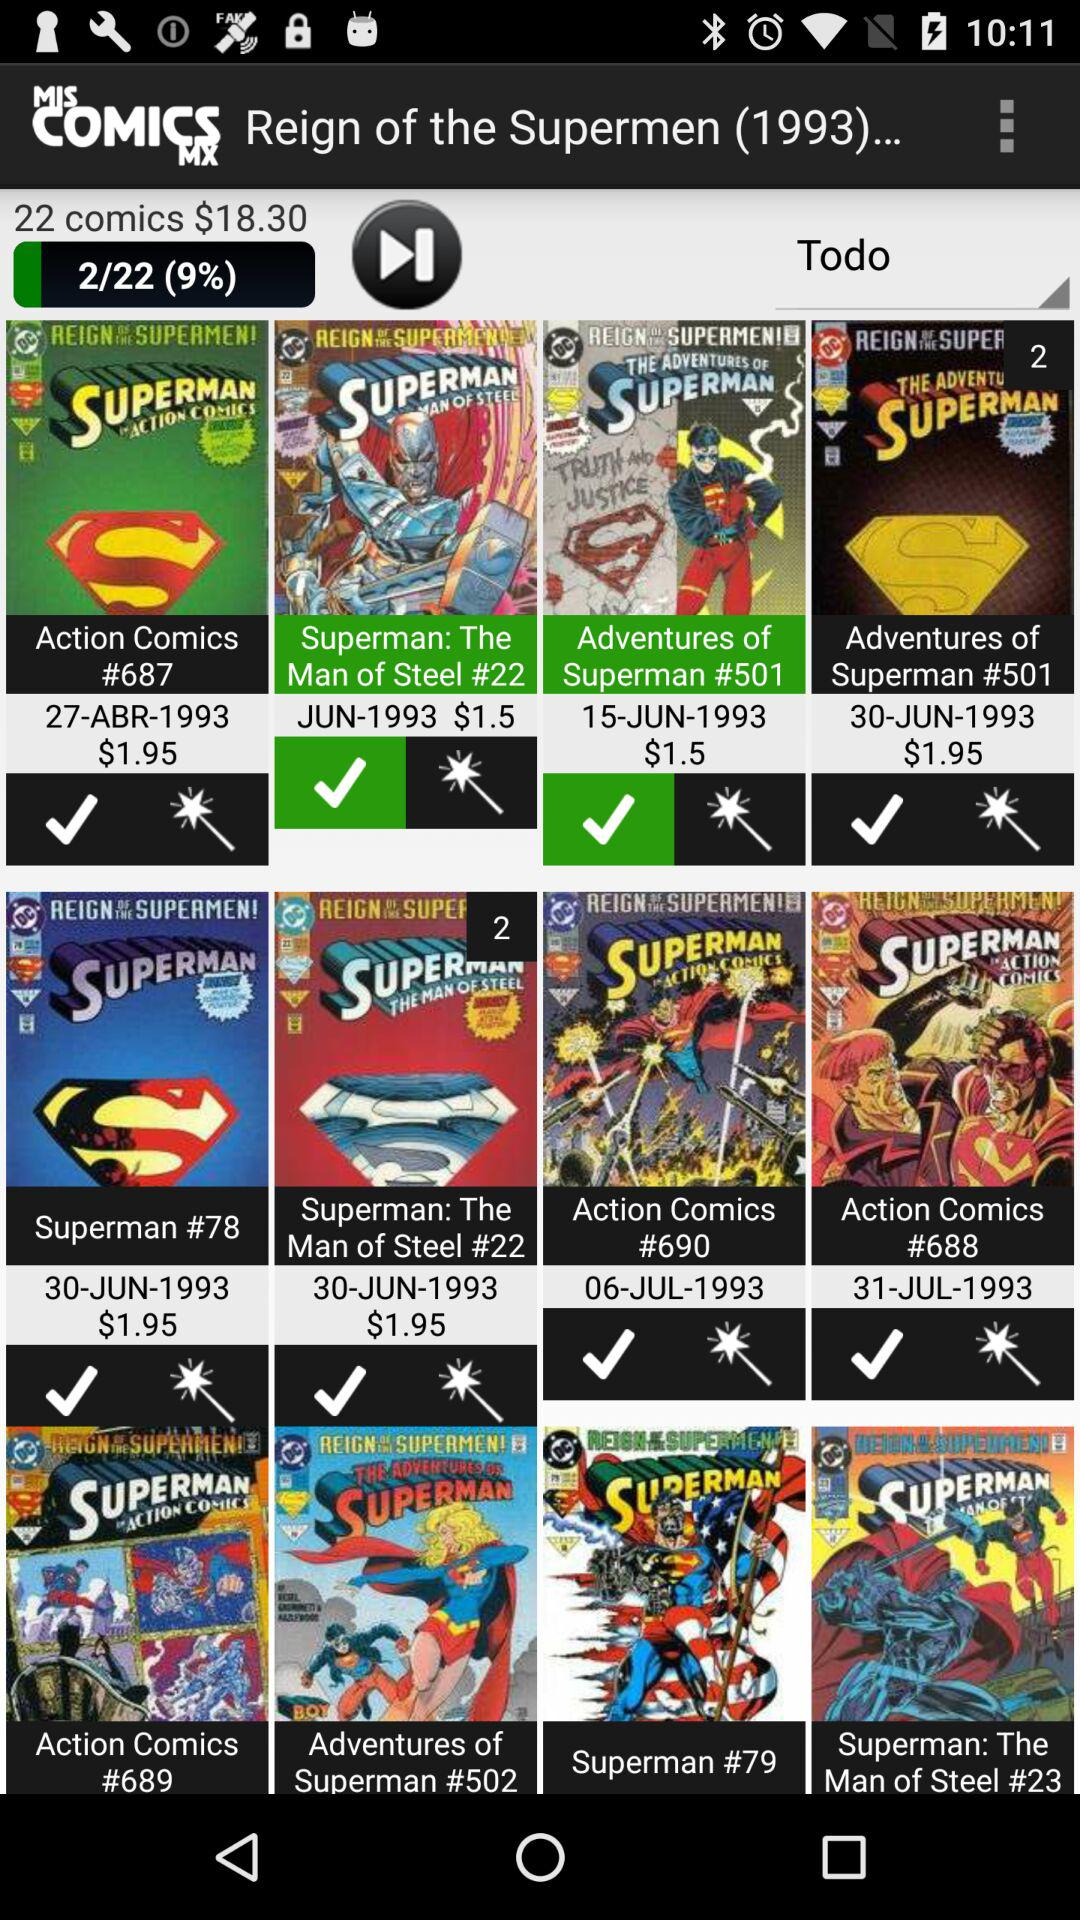What is the price of the "Superman #78"? The price of the "Superman #78" is $1.95. 